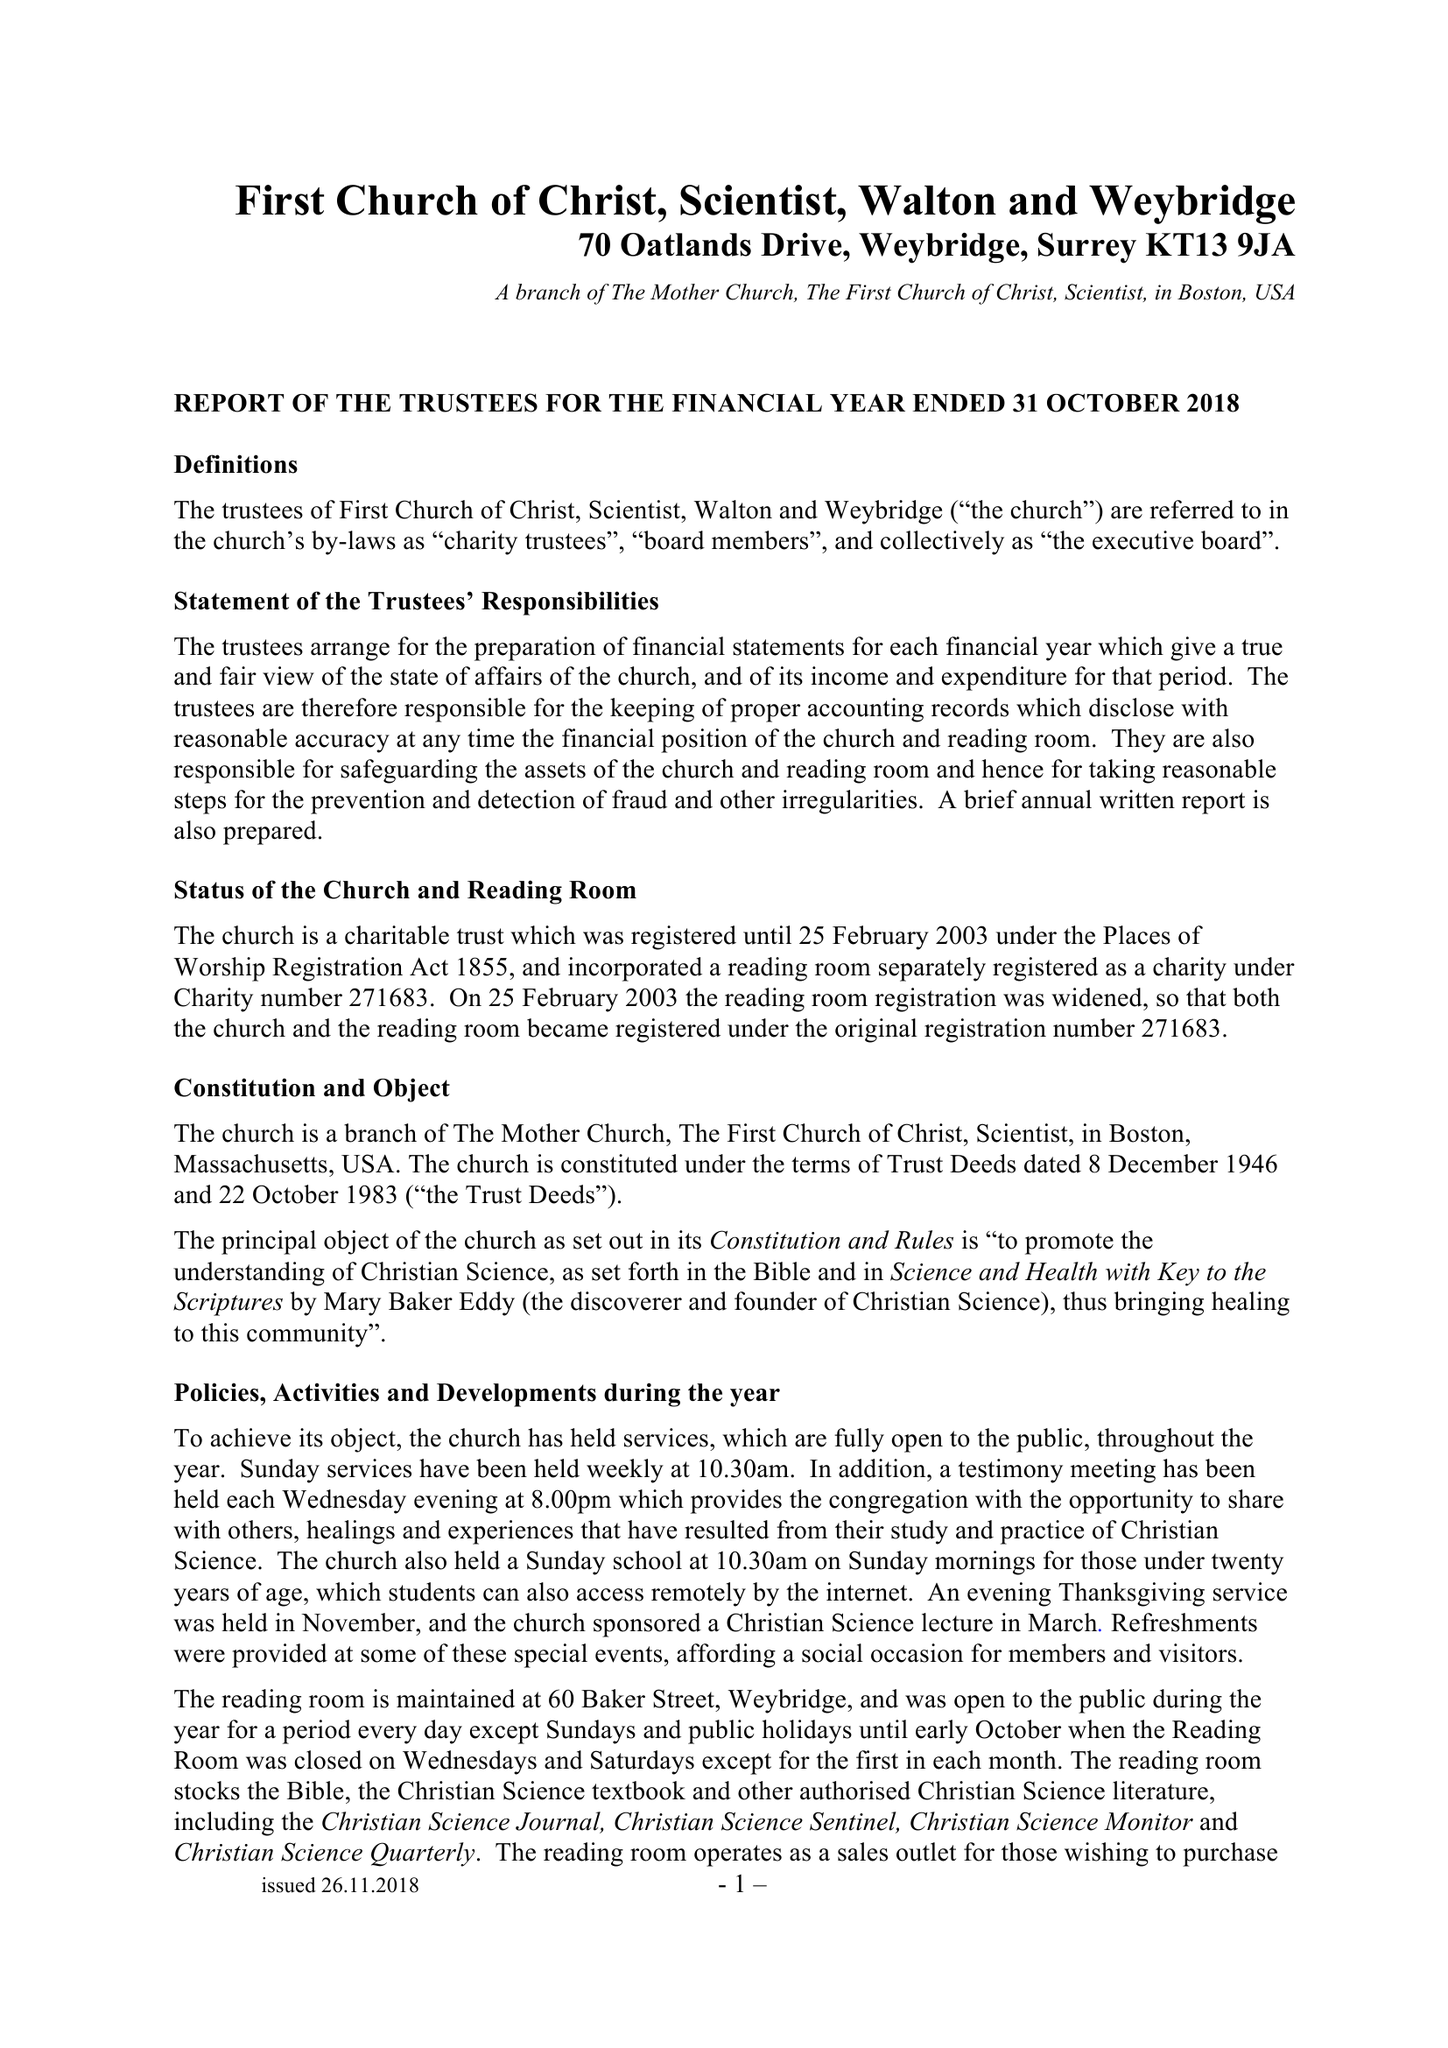What is the value for the charity_number?
Answer the question using a single word or phrase. 271683 